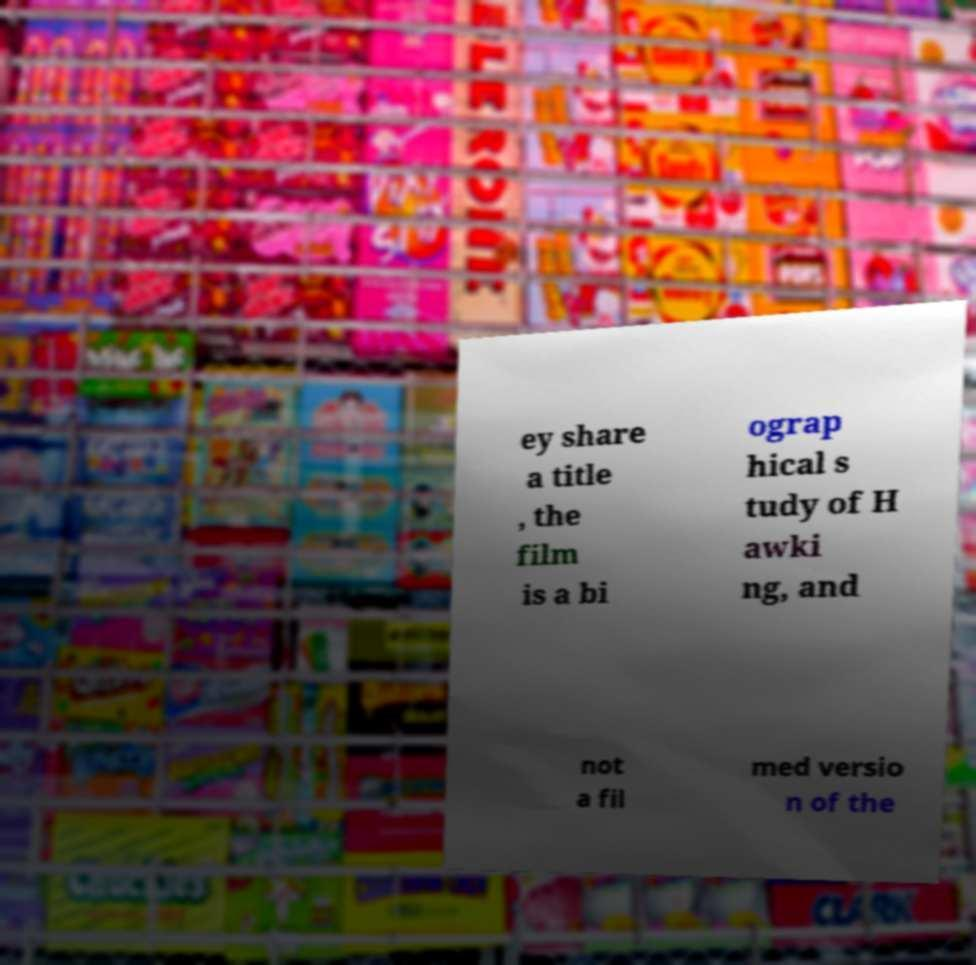Please read and relay the text visible in this image. What does it say? ey share a title , the film is a bi ograp hical s tudy of H awki ng, and not a fil med versio n of the 